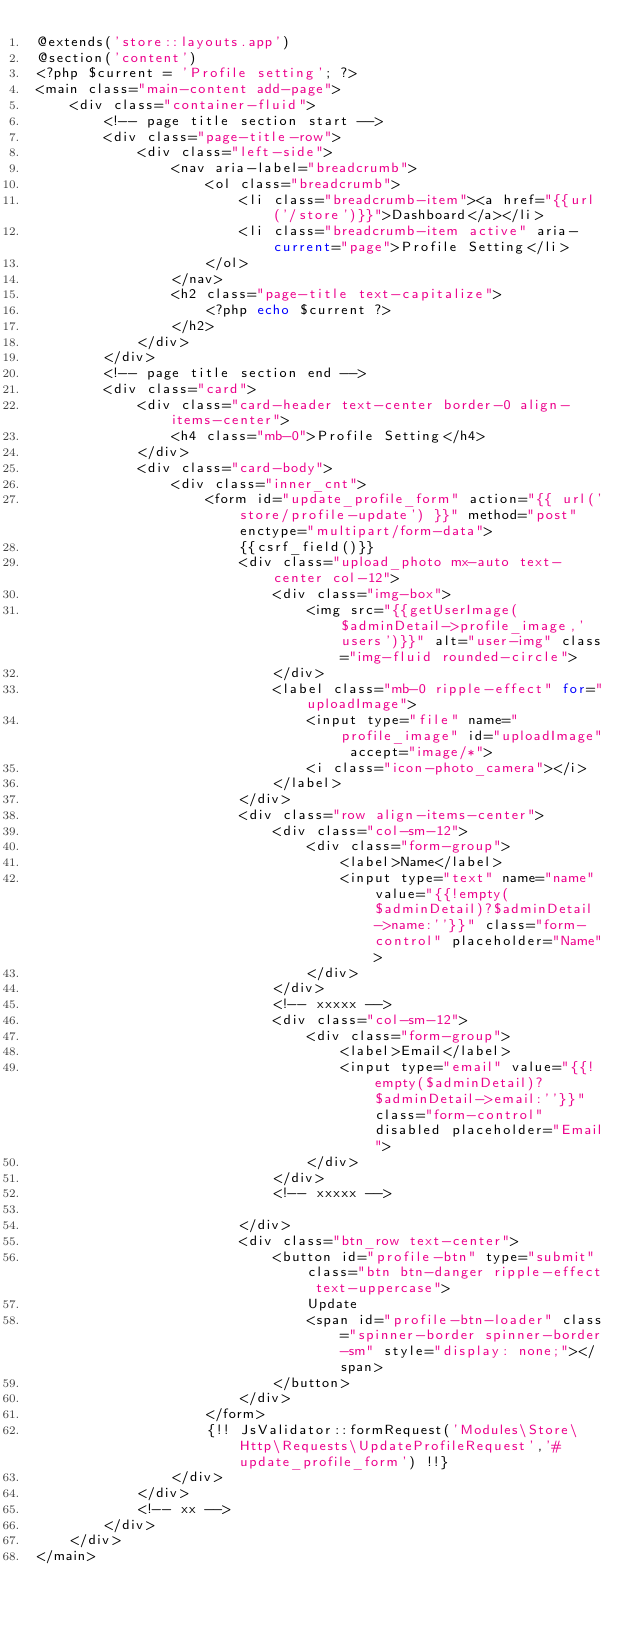<code> <loc_0><loc_0><loc_500><loc_500><_PHP_>@extends('store::layouts.app')
@section('content')
<?php $current = 'Profile setting'; ?>
<main class="main-content add-page">
    <div class="container-fluid">
        <!-- page title section start -->
        <div class="page-title-row">
            <div class="left-side">
                <nav aria-label="breadcrumb">
                    <ol class="breadcrumb">
                        <li class="breadcrumb-item"><a href="{{url('/store')}}">Dashboard</a></li>
                        <li class="breadcrumb-item active" aria-current="page">Profile Setting</li>
                    </ol>
                </nav>
                <h2 class="page-title text-capitalize">
                    <?php echo $current ?>
                </h2>
            </div>
        </div>
        <!-- page title section end -->
        <div class="card">
            <div class="card-header text-center border-0 align-items-center">
                <h4 class="mb-0">Profile Setting</h4>
            </div>
            <div class="card-body">
                <div class="inner_cnt">
                    <form id="update_profile_form" action="{{ url('store/profile-update') }}" method="post" enctype="multipart/form-data">
                        {{csrf_field()}}
                        <div class="upload_photo mx-auto text-center col-12">
                            <div class="img-box">
                                <img src="{{getUserImage($adminDetail->profile_image,'users')}}" alt="user-img" class="img-fluid rounded-circle">
                            </div>
                            <label class="mb-0 ripple-effect" for="uploadImage">
                                <input type="file" name="profile_image" id="uploadImage" accept="image/*">
                                <i class="icon-photo_camera"></i>
                            </label>
                        </div>
                        <div class="row align-items-center">
                            <div class="col-sm-12">
                                <div class="form-group">
                                    <label>Name</label>
                                    <input type="text" name="name" value="{{!empty($adminDetail)?$adminDetail->name:''}}" class="form-control" placeholder="Name">
                                </div>
                            </div>
                            <!-- xxxxx -->
                            <div class="col-sm-12">
                                <div class="form-group">
                                    <label>Email</label>
                                    <input type="email" value="{{!empty($adminDetail)?$adminDetail->email:''}}" class="form-control" disabled placeholder="Email">
                                </div>
                            </div>
                            <!-- xxxxx -->

                        </div>
                        <div class="btn_row text-center">
                            <button id="profile-btn" type="submit" class="btn btn-danger ripple-effect text-uppercase">
                                Update
                                <span id="profile-btn-loader" class="spinner-border spinner-border-sm" style="display: none;"></span>
                            </button>
                        </div>
                    </form>
                    {!! JsValidator::formRequest('Modules\Store\Http\Requests\UpdateProfileRequest','#update_profile_form') !!}
                </div>
            </div>
            <!-- xx -->
        </div>
    </div>
</main></code> 